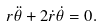<formula> <loc_0><loc_0><loc_500><loc_500>r \ddot { \theta } + 2 \dot { r } \dot { \theta } & = 0 .</formula> 